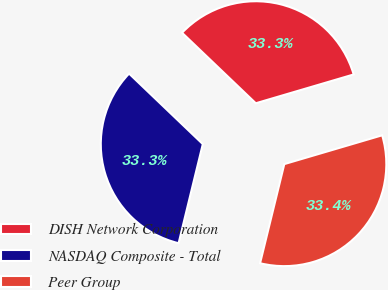<chart> <loc_0><loc_0><loc_500><loc_500><pie_chart><fcel>DISH Network Corporation<fcel>NASDAQ Composite - Total<fcel>Peer Group<nl><fcel>33.3%<fcel>33.33%<fcel>33.37%<nl></chart> 